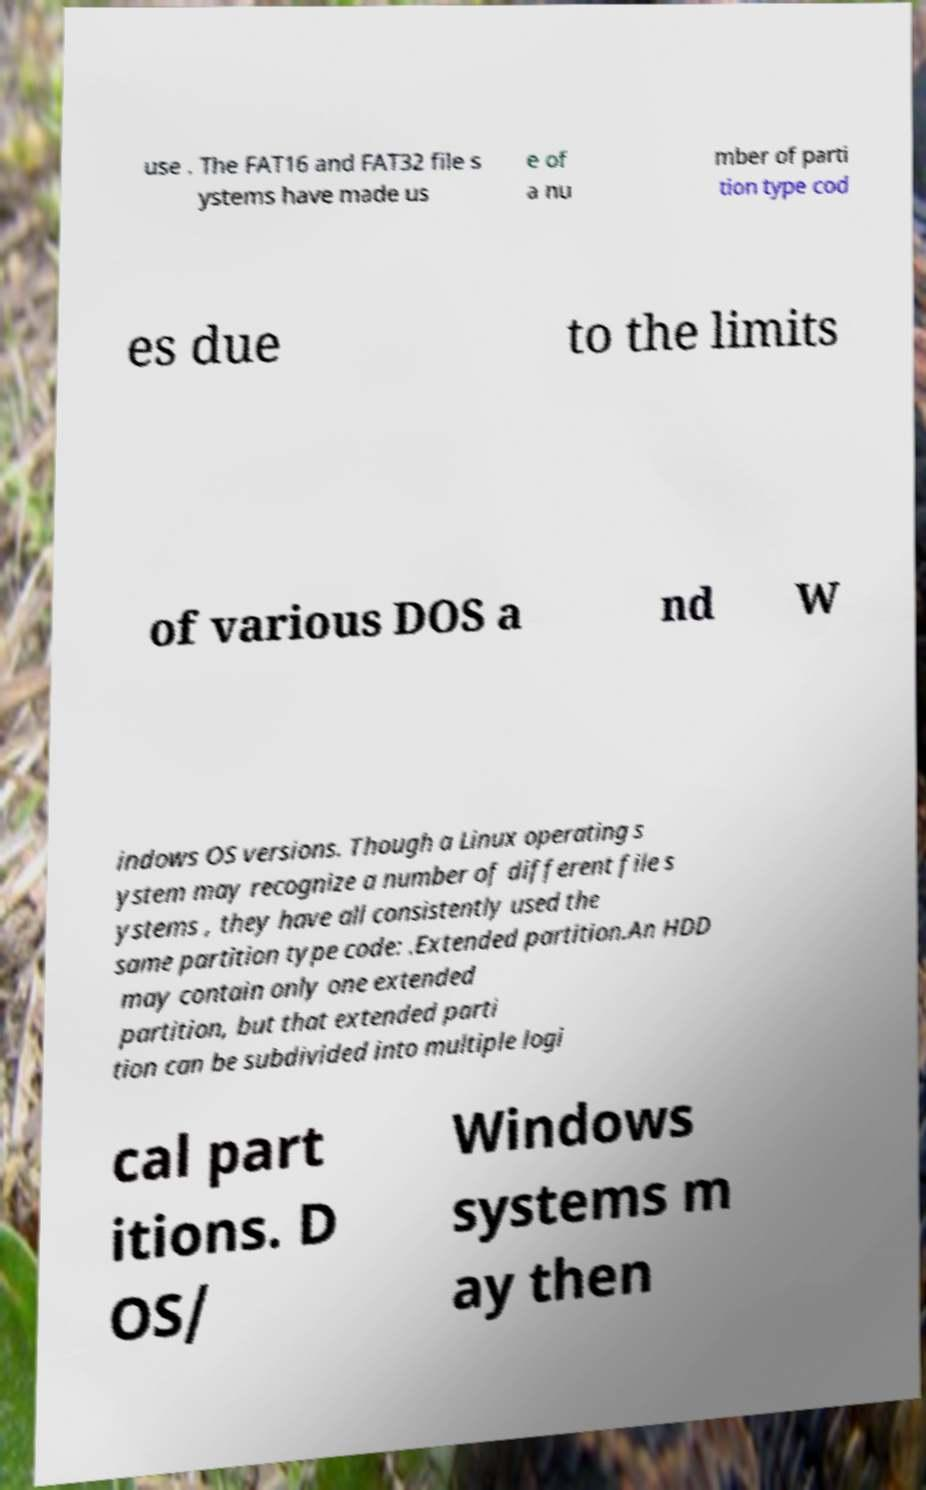Please read and relay the text visible in this image. What does it say? use . The FAT16 and FAT32 file s ystems have made us e of a nu mber of parti tion type cod es due to the limits of various DOS a nd W indows OS versions. Though a Linux operating s ystem may recognize a number of different file s ystems , they have all consistently used the same partition type code: .Extended partition.An HDD may contain only one extended partition, but that extended parti tion can be subdivided into multiple logi cal part itions. D OS/ Windows systems m ay then 